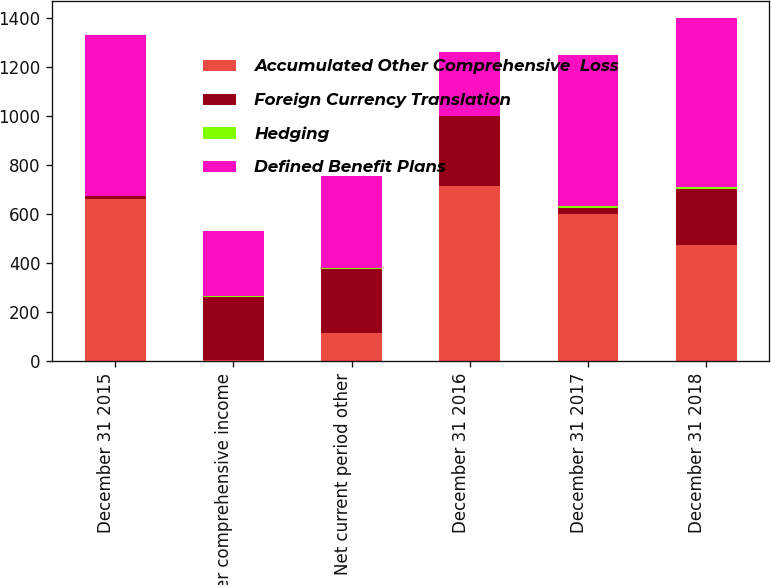Convert chart to OTSL. <chart><loc_0><loc_0><loc_500><loc_500><stacked_bar_chart><ecel><fcel>December 31 2015<fcel>Other comprehensive income<fcel>Net current period other<fcel>December 31 2016<fcel>December 31 2017<fcel>December 31 2018<nl><fcel>Accumulated Other Comprehensive  Loss<fcel>662<fcel>3<fcel>115<fcel>713<fcel>598<fcel>472<nl><fcel>Foreign Currency Translation<fcel>11<fcel>259<fcel>259<fcel>285<fcel>26<fcel>228<nl><fcel>Hedging<fcel>2<fcel>4<fcel>4<fcel>3<fcel>7<fcel>8<nl><fcel>Defined Benefit Plans<fcel>653<fcel>266<fcel>378<fcel>259<fcel>617<fcel>692<nl></chart> 